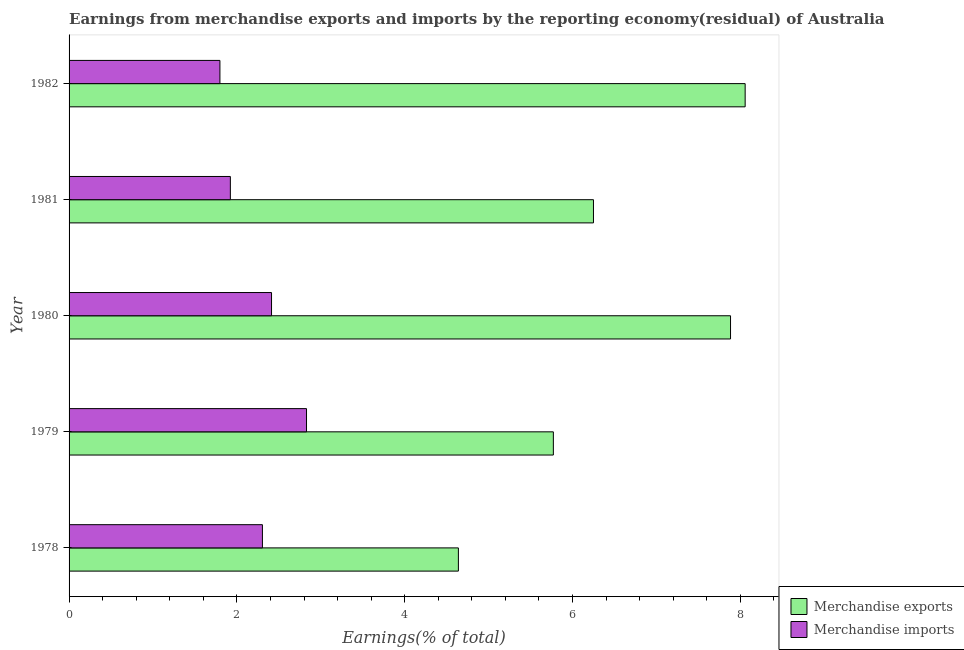How many different coloured bars are there?
Your answer should be compact. 2. Are the number of bars per tick equal to the number of legend labels?
Ensure brevity in your answer.  Yes. Are the number of bars on each tick of the Y-axis equal?
Give a very brief answer. Yes. How many bars are there on the 3rd tick from the top?
Ensure brevity in your answer.  2. What is the label of the 2nd group of bars from the top?
Offer a very short reply. 1981. In how many cases, is the number of bars for a given year not equal to the number of legend labels?
Ensure brevity in your answer.  0. What is the earnings from merchandise imports in 1982?
Your answer should be very brief. 1.8. Across all years, what is the maximum earnings from merchandise imports?
Give a very brief answer. 2.83. Across all years, what is the minimum earnings from merchandise imports?
Provide a succinct answer. 1.8. In which year was the earnings from merchandise imports maximum?
Your answer should be very brief. 1979. In which year was the earnings from merchandise exports minimum?
Provide a short and direct response. 1978. What is the total earnings from merchandise imports in the graph?
Make the answer very short. 11.27. What is the difference between the earnings from merchandise imports in 1979 and that in 1982?
Your answer should be very brief. 1.03. What is the difference between the earnings from merchandise imports in 1981 and the earnings from merchandise exports in 1980?
Your answer should be compact. -5.96. What is the average earnings from merchandise imports per year?
Your response must be concise. 2.25. In the year 1982, what is the difference between the earnings from merchandise exports and earnings from merchandise imports?
Your answer should be very brief. 6.26. What is the ratio of the earnings from merchandise imports in 1978 to that in 1980?
Your answer should be very brief. 0.95. Is the earnings from merchandise exports in 1978 less than that in 1979?
Your response must be concise. Yes. What is the difference between the highest and the second highest earnings from merchandise imports?
Ensure brevity in your answer.  0.42. What is the difference between the highest and the lowest earnings from merchandise exports?
Give a very brief answer. 3.42. In how many years, is the earnings from merchandise imports greater than the average earnings from merchandise imports taken over all years?
Give a very brief answer. 3. Is the sum of the earnings from merchandise imports in 1979 and 1980 greater than the maximum earnings from merchandise exports across all years?
Your answer should be very brief. No. What does the 1st bar from the top in 1981 represents?
Offer a very short reply. Merchandise imports. What does the 2nd bar from the bottom in 1979 represents?
Keep it short and to the point. Merchandise imports. How many years are there in the graph?
Your answer should be very brief. 5. Are the values on the major ticks of X-axis written in scientific E-notation?
Offer a very short reply. No. Does the graph contain any zero values?
Give a very brief answer. No. What is the title of the graph?
Your response must be concise. Earnings from merchandise exports and imports by the reporting economy(residual) of Australia. Does "Net savings(excluding particulate emission damage)" appear as one of the legend labels in the graph?
Your answer should be very brief. No. What is the label or title of the X-axis?
Keep it short and to the point. Earnings(% of total). What is the label or title of the Y-axis?
Offer a very short reply. Year. What is the Earnings(% of total) of Merchandise exports in 1978?
Make the answer very short. 4.64. What is the Earnings(% of total) of Merchandise imports in 1978?
Your answer should be compact. 2.3. What is the Earnings(% of total) of Merchandise exports in 1979?
Provide a short and direct response. 5.77. What is the Earnings(% of total) in Merchandise imports in 1979?
Your response must be concise. 2.83. What is the Earnings(% of total) in Merchandise exports in 1980?
Your answer should be very brief. 7.88. What is the Earnings(% of total) in Merchandise imports in 1980?
Provide a short and direct response. 2.41. What is the Earnings(% of total) of Merchandise exports in 1981?
Offer a terse response. 6.25. What is the Earnings(% of total) in Merchandise imports in 1981?
Your response must be concise. 1.92. What is the Earnings(% of total) in Merchandise exports in 1982?
Your answer should be compact. 8.06. What is the Earnings(% of total) in Merchandise imports in 1982?
Offer a terse response. 1.8. Across all years, what is the maximum Earnings(% of total) in Merchandise exports?
Your answer should be very brief. 8.06. Across all years, what is the maximum Earnings(% of total) of Merchandise imports?
Your answer should be compact. 2.83. Across all years, what is the minimum Earnings(% of total) in Merchandise exports?
Offer a very short reply. 4.64. Across all years, what is the minimum Earnings(% of total) in Merchandise imports?
Make the answer very short. 1.8. What is the total Earnings(% of total) in Merchandise exports in the graph?
Your answer should be compact. 32.6. What is the total Earnings(% of total) in Merchandise imports in the graph?
Offer a very short reply. 11.27. What is the difference between the Earnings(% of total) in Merchandise exports in 1978 and that in 1979?
Your answer should be very brief. -1.13. What is the difference between the Earnings(% of total) of Merchandise imports in 1978 and that in 1979?
Make the answer very short. -0.53. What is the difference between the Earnings(% of total) of Merchandise exports in 1978 and that in 1980?
Your response must be concise. -3.24. What is the difference between the Earnings(% of total) in Merchandise imports in 1978 and that in 1980?
Your answer should be compact. -0.11. What is the difference between the Earnings(% of total) of Merchandise exports in 1978 and that in 1981?
Offer a very short reply. -1.61. What is the difference between the Earnings(% of total) of Merchandise imports in 1978 and that in 1981?
Provide a succinct answer. 0.38. What is the difference between the Earnings(% of total) in Merchandise exports in 1978 and that in 1982?
Make the answer very short. -3.42. What is the difference between the Earnings(% of total) in Merchandise imports in 1978 and that in 1982?
Offer a terse response. 0.51. What is the difference between the Earnings(% of total) in Merchandise exports in 1979 and that in 1980?
Give a very brief answer. -2.11. What is the difference between the Earnings(% of total) in Merchandise imports in 1979 and that in 1980?
Make the answer very short. 0.42. What is the difference between the Earnings(% of total) in Merchandise exports in 1979 and that in 1981?
Your answer should be very brief. -0.48. What is the difference between the Earnings(% of total) in Merchandise imports in 1979 and that in 1981?
Provide a short and direct response. 0.91. What is the difference between the Earnings(% of total) in Merchandise exports in 1979 and that in 1982?
Provide a succinct answer. -2.29. What is the difference between the Earnings(% of total) of Merchandise imports in 1979 and that in 1982?
Your response must be concise. 1.03. What is the difference between the Earnings(% of total) in Merchandise exports in 1980 and that in 1981?
Make the answer very short. 1.63. What is the difference between the Earnings(% of total) of Merchandise imports in 1980 and that in 1981?
Provide a succinct answer. 0.49. What is the difference between the Earnings(% of total) of Merchandise exports in 1980 and that in 1982?
Your response must be concise. -0.17. What is the difference between the Earnings(% of total) of Merchandise imports in 1980 and that in 1982?
Ensure brevity in your answer.  0.61. What is the difference between the Earnings(% of total) of Merchandise exports in 1981 and that in 1982?
Offer a terse response. -1.81. What is the difference between the Earnings(% of total) of Merchandise imports in 1981 and that in 1982?
Keep it short and to the point. 0.12. What is the difference between the Earnings(% of total) in Merchandise exports in 1978 and the Earnings(% of total) in Merchandise imports in 1979?
Provide a succinct answer. 1.81. What is the difference between the Earnings(% of total) in Merchandise exports in 1978 and the Earnings(% of total) in Merchandise imports in 1980?
Your answer should be very brief. 2.23. What is the difference between the Earnings(% of total) of Merchandise exports in 1978 and the Earnings(% of total) of Merchandise imports in 1981?
Your response must be concise. 2.72. What is the difference between the Earnings(% of total) in Merchandise exports in 1978 and the Earnings(% of total) in Merchandise imports in 1982?
Give a very brief answer. 2.84. What is the difference between the Earnings(% of total) of Merchandise exports in 1979 and the Earnings(% of total) of Merchandise imports in 1980?
Provide a short and direct response. 3.36. What is the difference between the Earnings(% of total) of Merchandise exports in 1979 and the Earnings(% of total) of Merchandise imports in 1981?
Your answer should be compact. 3.85. What is the difference between the Earnings(% of total) in Merchandise exports in 1979 and the Earnings(% of total) in Merchandise imports in 1982?
Provide a succinct answer. 3.97. What is the difference between the Earnings(% of total) in Merchandise exports in 1980 and the Earnings(% of total) in Merchandise imports in 1981?
Keep it short and to the point. 5.96. What is the difference between the Earnings(% of total) of Merchandise exports in 1980 and the Earnings(% of total) of Merchandise imports in 1982?
Your answer should be very brief. 6.09. What is the difference between the Earnings(% of total) of Merchandise exports in 1981 and the Earnings(% of total) of Merchandise imports in 1982?
Provide a succinct answer. 4.45. What is the average Earnings(% of total) of Merchandise exports per year?
Your answer should be compact. 6.52. What is the average Earnings(% of total) in Merchandise imports per year?
Your answer should be very brief. 2.25. In the year 1978, what is the difference between the Earnings(% of total) of Merchandise exports and Earnings(% of total) of Merchandise imports?
Ensure brevity in your answer.  2.34. In the year 1979, what is the difference between the Earnings(% of total) in Merchandise exports and Earnings(% of total) in Merchandise imports?
Give a very brief answer. 2.94. In the year 1980, what is the difference between the Earnings(% of total) of Merchandise exports and Earnings(% of total) of Merchandise imports?
Provide a succinct answer. 5.47. In the year 1981, what is the difference between the Earnings(% of total) in Merchandise exports and Earnings(% of total) in Merchandise imports?
Make the answer very short. 4.33. In the year 1982, what is the difference between the Earnings(% of total) in Merchandise exports and Earnings(% of total) in Merchandise imports?
Offer a terse response. 6.26. What is the ratio of the Earnings(% of total) of Merchandise exports in 1978 to that in 1979?
Offer a very short reply. 0.8. What is the ratio of the Earnings(% of total) in Merchandise imports in 1978 to that in 1979?
Give a very brief answer. 0.81. What is the ratio of the Earnings(% of total) of Merchandise exports in 1978 to that in 1980?
Keep it short and to the point. 0.59. What is the ratio of the Earnings(% of total) of Merchandise imports in 1978 to that in 1980?
Give a very brief answer. 0.95. What is the ratio of the Earnings(% of total) of Merchandise exports in 1978 to that in 1981?
Provide a short and direct response. 0.74. What is the ratio of the Earnings(% of total) in Merchandise imports in 1978 to that in 1981?
Give a very brief answer. 1.2. What is the ratio of the Earnings(% of total) of Merchandise exports in 1978 to that in 1982?
Provide a short and direct response. 0.58. What is the ratio of the Earnings(% of total) of Merchandise imports in 1978 to that in 1982?
Provide a succinct answer. 1.28. What is the ratio of the Earnings(% of total) in Merchandise exports in 1979 to that in 1980?
Offer a very short reply. 0.73. What is the ratio of the Earnings(% of total) of Merchandise imports in 1979 to that in 1980?
Provide a short and direct response. 1.17. What is the ratio of the Earnings(% of total) of Merchandise exports in 1979 to that in 1981?
Offer a terse response. 0.92. What is the ratio of the Earnings(% of total) in Merchandise imports in 1979 to that in 1981?
Keep it short and to the point. 1.47. What is the ratio of the Earnings(% of total) of Merchandise exports in 1979 to that in 1982?
Give a very brief answer. 0.72. What is the ratio of the Earnings(% of total) of Merchandise imports in 1979 to that in 1982?
Offer a very short reply. 1.57. What is the ratio of the Earnings(% of total) of Merchandise exports in 1980 to that in 1981?
Your answer should be very brief. 1.26. What is the ratio of the Earnings(% of total) in Merchandise imports in 1980 to that in 1981?
Make the answer very short. 1.26. What is the ratio of the Earnings(% of total) in Merchandise exports in 1980 to that in 1982?
Provide a succinct answer. 0.98. What is the ratio of the Earnings(% of total) in Merchandise imports in 1980 to that in 1982?
Give a very brief answer. 1.34. What is the ratio of the Earnings(% of total) in Merchandise exports in 1981 to that in 1982?
Your answer should be very brief. 0.78. What is the ratio of the Earnings(% of total) in Merchandise imports in 1981 to that in 1982?
Your answer should be compact. 1.07. What is the difference between the highest and the second highest Earnings(% of total) of Merchandise exports?
Make the answer very short. 0.17. What is the difference between the highest and the second highest Earnings(% of total) of Merchandise imports?
Your response must be concise. 0.42. What is the difference between the highest and the lowest Earnings(% of total) in Merchandise exports?
Give a very brief answer. 3.42. What is the difference between the highest and the lowest Earnings(% of total) in Merchandise imports?
Your answer should be very brief. 1.03. 